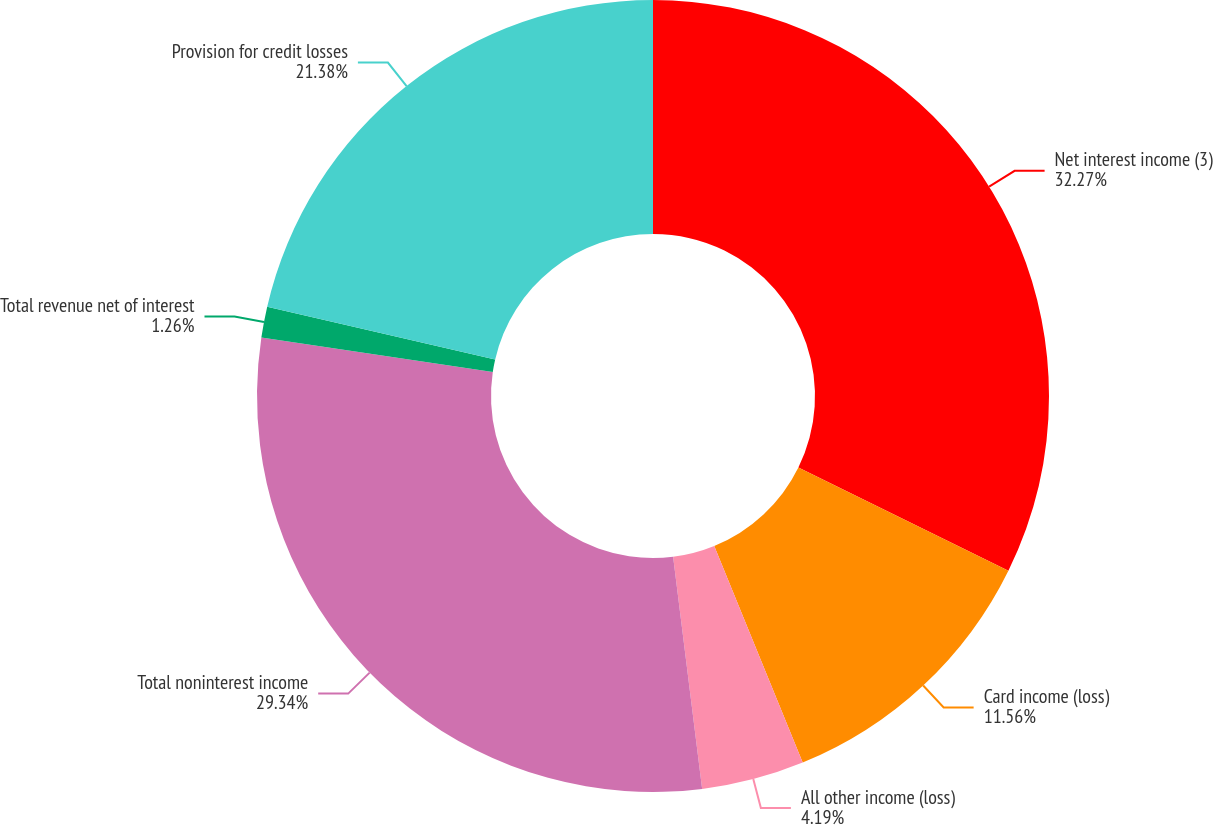Convert chart. <chart><loc_0><loc_0><loc_500><loc_500><pie_chart><fcel>Net interest income (3)<fcel>Card income (loss)<fcel>All other income (loss)<fcel>Total noninterest income<fcel>Total revenue net of interest<fcel>Provision for credit losses<nl><fcel>32.27%<fcel>11.56%<fcel>4.19%<fcel>29.34%<fcel>1.26%<fcel>21.38%<nl></chart> 